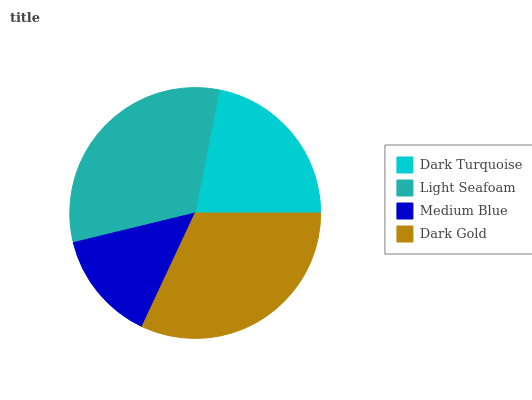Is Medium Blue the minimum?
Answer yes or no. Yes. Is Dark Gold the maximum?
Answer yes or no. Yes. Is Light Seafoam the minimum?
Answer yes or no. No. Is Light Seafoam the maximum?
Answer yes or no. No. Is Light Seafoam greater than Dark Turquoise?
Answer yes or no. Yes. Is Dark Turquoise less than Light Seafoam?
Answer yes or no. Yes. Is Dark Turquoise greater than Light Seafoam?
Answer yes or no. No. Is Light Seafoam less than Dark Turquoise?
Answer yes or no. No. Is Light Seafoam the high median?
Answer yes or no. Yes. Is Dark Turquoise the low median?
Answer yes or no. Yes. Is Medium Blue the high median?
Answer yes or no. No. Is Light Seafoam the low median?
Answer yes or no. No. 